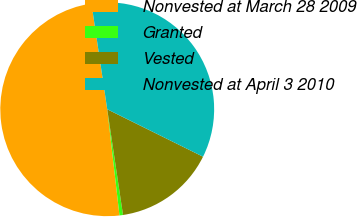Convert chart. <chart><loc_0><loc_0><loc_500><loc_500><pie_chart><fcel>Nonvested at March 28 2009<fcel>Granted<fcel>Vested<fcel>Nonvested at April 3 2010<nl><fcel>49.47%<fcel>0.53%<fcel>15.32%<fcel>34.68%<nl></chart> 